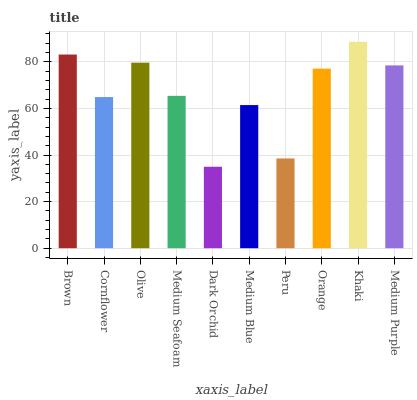Is Cornflower the minimum?
Answer yes or no. No. Is Cornflower the maximum?
Answer yes or no. No. Is Brown greater than Cornflower?
Answer yes or no. Yes. Is Cornflower less than Brown?
Answer yes or no. Yes. Is Cornflower greater than Brown?
Answer yes or no. No. Is Brown less than Cornflower?
Answer yes or no. No. Is Orange the high median?
Answer yes or no. Yes. Is Medium Seafoam the low median?
Answer yes or no. Yes. Is Medium Seafoam the high median?
Answer yes or no. No. Is Brown the low median?
Answer yes or no. No. 